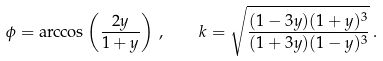<formula> <loc_0><loc_0><loc_500><loc_500>\phi = \arccos \left ( \frac { 2 y } { 1 + y } \right ) \, , \quad k = \sqrt { \frac { ( 1 - 3 y ) ( 1 + y ) ^ { 3 } } { ( 1 + 3 y ) ( 1 - y ) ^ { 3 } } } \, .</formula> 